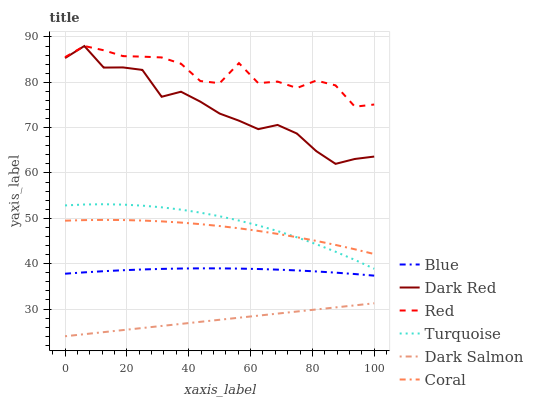Does Dark Salmon have the minimum area under the curve?
Answer yes or no. Yes. Does Red have the maximum area under the curve?
Answer yes or no. Yes. Does Turquoise have the minimum area under the curve?
Answer yes or no. No. Does Turquoise have the maximum area under the curve?
Answer yes or no. No. Is Dark Salmon the smoothest?
Answer yes or no. Yes. Is Red the roughest?
Answer yes or no. Yes. Is Turquoise the smoothest?
Answer yes or no. No. Is Turquoise the roughest?
Answer yes or no. No. Does Dark Salmon have the lowest value?
Answer yes or no. Yes. Does Turquoise have the lowest value?
Answer yes or no. No. Does Red have the highest value?
Answer yes or no. Yes. Does Turquoise have the highest value?
Answer yes or no. No. Is Turquoise less than Dark Red?
Answer yes or no. Yes. Is Turquoise greater than Blue?
Answer yes or no. Yes. Does Coral intersect Turquoise?
Answer yes or no. Yes. Is Coral less than Turquoise?
Answer yes or no. No. Is Coral greater than Turquoise?
Answer yes or no. No. Does Turquoise intersect Dark Red?
Answer yes or no. No. 